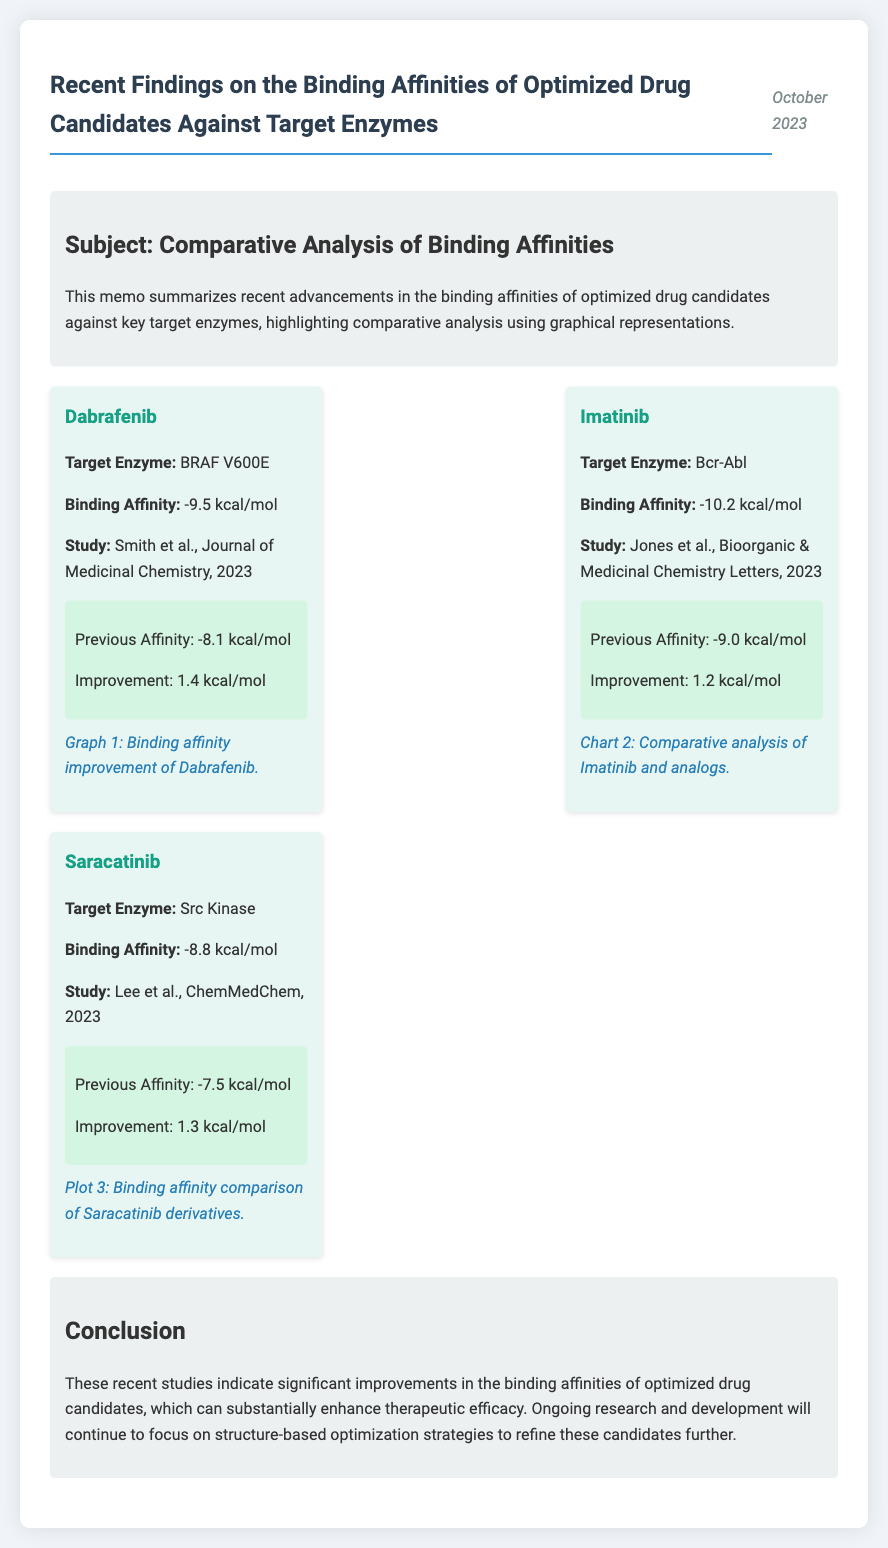What is the binding affinity of Dabrafenib? The binding affinity of Dabrafenib is stated as -9.5 kcal/mol in the document.
Answer: -9.5 kcal/mol Who conducted the study on Imatinib? The study on Imatinib was conducted by Jones et al., as mentioned in the document.
Answer: Jones et al What is the improvement in binding affinity for Saracatinib? The improvement in binding affinity for Saracatinib is calculated from the previous affinity and the current affinity, which is 1.3 kcal/mol.
Answer: 1.3 kcal/mol Which target enzyme is associated with Imatinib? The target enzyme associated with Imatinib is mentioned as Bcr-Abl.
Answer: Bcr-Abl What is the date of the memo? The memo is dated October 2023, as provided in the document.
Answer: October 2023 How many drug candidates are analyzed in the memo? The memo presents findings on three optimized drug candidates, as listed under the findings section.
Answer: Three What is the previous binding affinity of Dabrafenib? The previous binding affinity of Dabrafenib is stated as -8.1 kcal/mol in the memo.
Answer: -8.1 kcal/mol What type of analysis is used to represent the findings? The document highlights the use of comparative analysis with graphical representations.
Answer: Comparative analysis What enzyme does Saracatinib target? Saracatinib targets Src Kinase, as detailed in the findings.
Answer: Src Kinase 